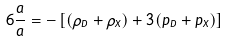Convert formula to latex. <formula><loc_0><loc_0><loc_500><loc_500>6 \frac { \ddot { a } } { a } = - \left [ ( \rho _ { D } + \rho _ { X } ) + 3 ( p _ { D } + p _ { X } ) \right ]</formula> 